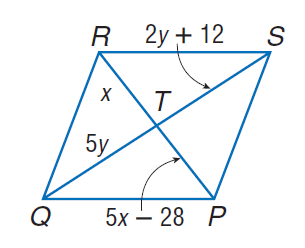Answer the mathemtical geometry problem and directly provide the correct option letter.
Question: Find x so that the quadrilateral is a parallelogram.
Choices: A: 7 B: 14 C: 21 D: 35 A 